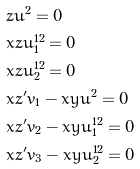Convert formula to latex. <formula><loc_0><loc_0><loc_500><loc_500>& z u ^ { 2 } = 0 \\ & x z u _ { 1 } ^ { 1 2 } = 0 \\ & x z u _ { 2 } ^ { 1 2 } = 0 \\ & x z ^ { \prime } v _ { 1 } - x y u ^ { 2 } = 0 \\ & x z ^ { \prime } v _ { 2 } - x y u _ { 1 } ^ { 1 2 } = 0 \\ & x z ^ { \prime } v _ { 3 } - x y u _ { 2 } ^ { 1 2 } = 0 \\</formula> 